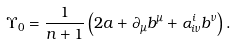<formula> <loc_0><loc_0><loc_500><loc_500>\Upsilon _ { 0 } = \frac { 1 } { n + 1 } \left ( 2 a + \partial _ { \mu } b ^ { \mu } + \alpha ^ { i } _ { i \nu } b ^ { \nu } \right ) .</formula> 